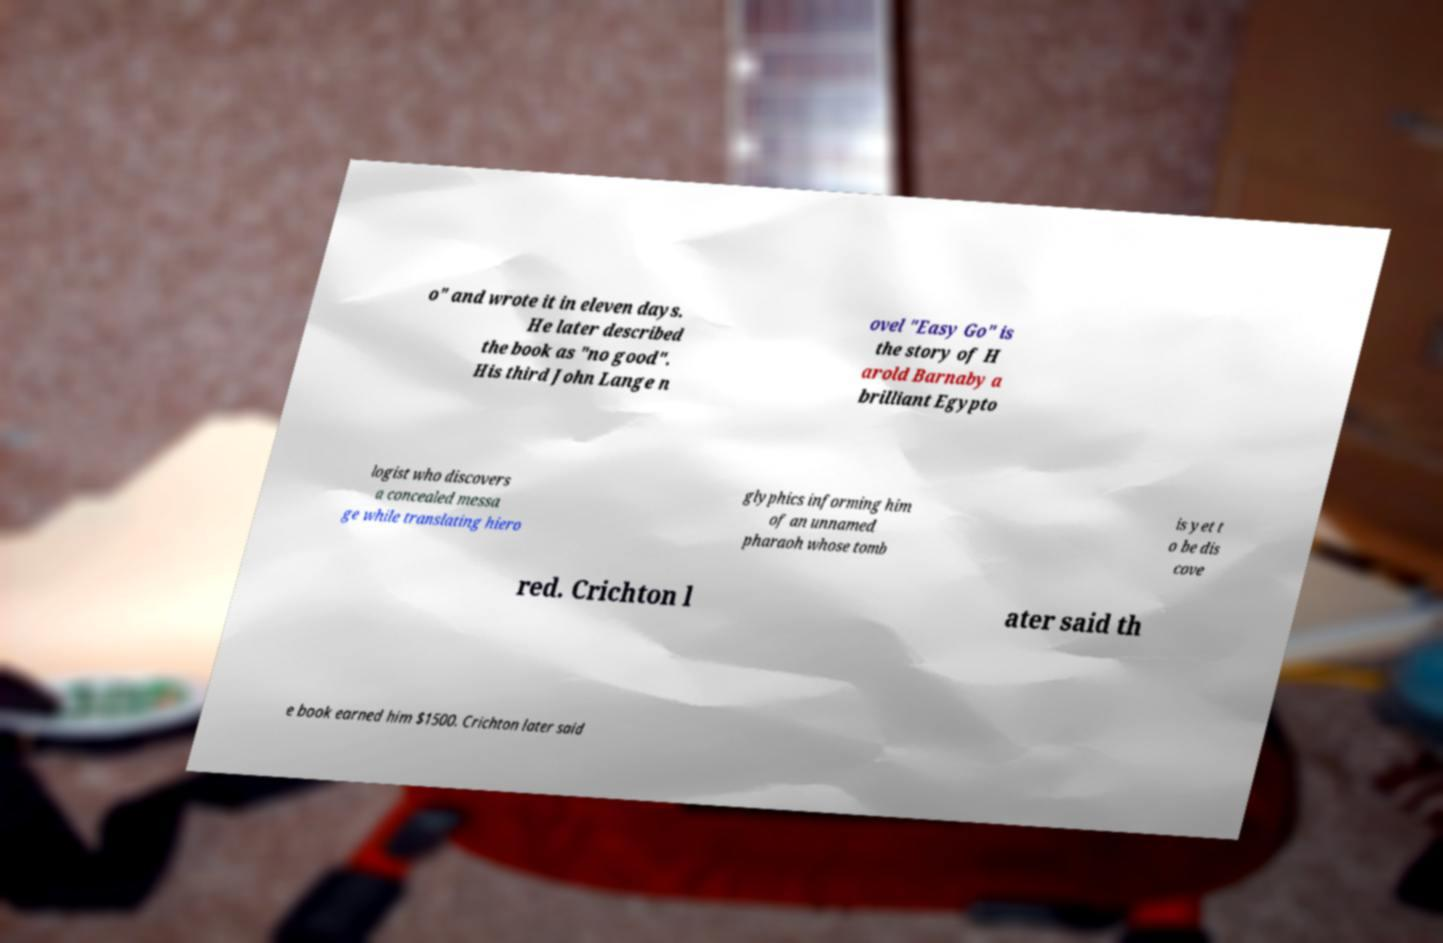Can you read and provide the text displayed in the image?This photo seems to have some interesting text. Can you extract and type it out for me? o" and wrote it in eleven days. He later described the book as "no good". His third John Lange n ovel "Easy Go" is the story of H arold Barnaby a brilliant Egypto logist who discovers a concealed messa ge while translating hiero glyphics informing him of an unnamed pharaoh whose tomb is yet t o be dis cove red. Crichton l ater said th e book earned him $1500. Crichton later said 